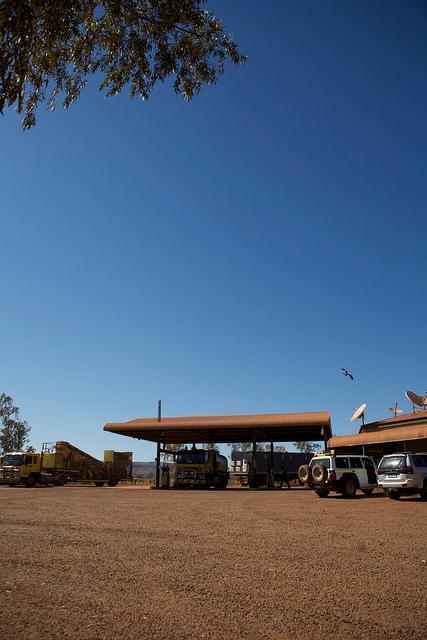How many white cars are in this picture?
Give a very brief answer. 2. How many people are in the photo?
Give a very brief answer. 0. How many bears are there?
Give a very brief answer. 0. How many cars are there?
Give a very brief answer. 1. How many trucks are in the picture?
Give a very brief answer. 3. How many motorcycles are here?
Give a very brief answer. 0. 